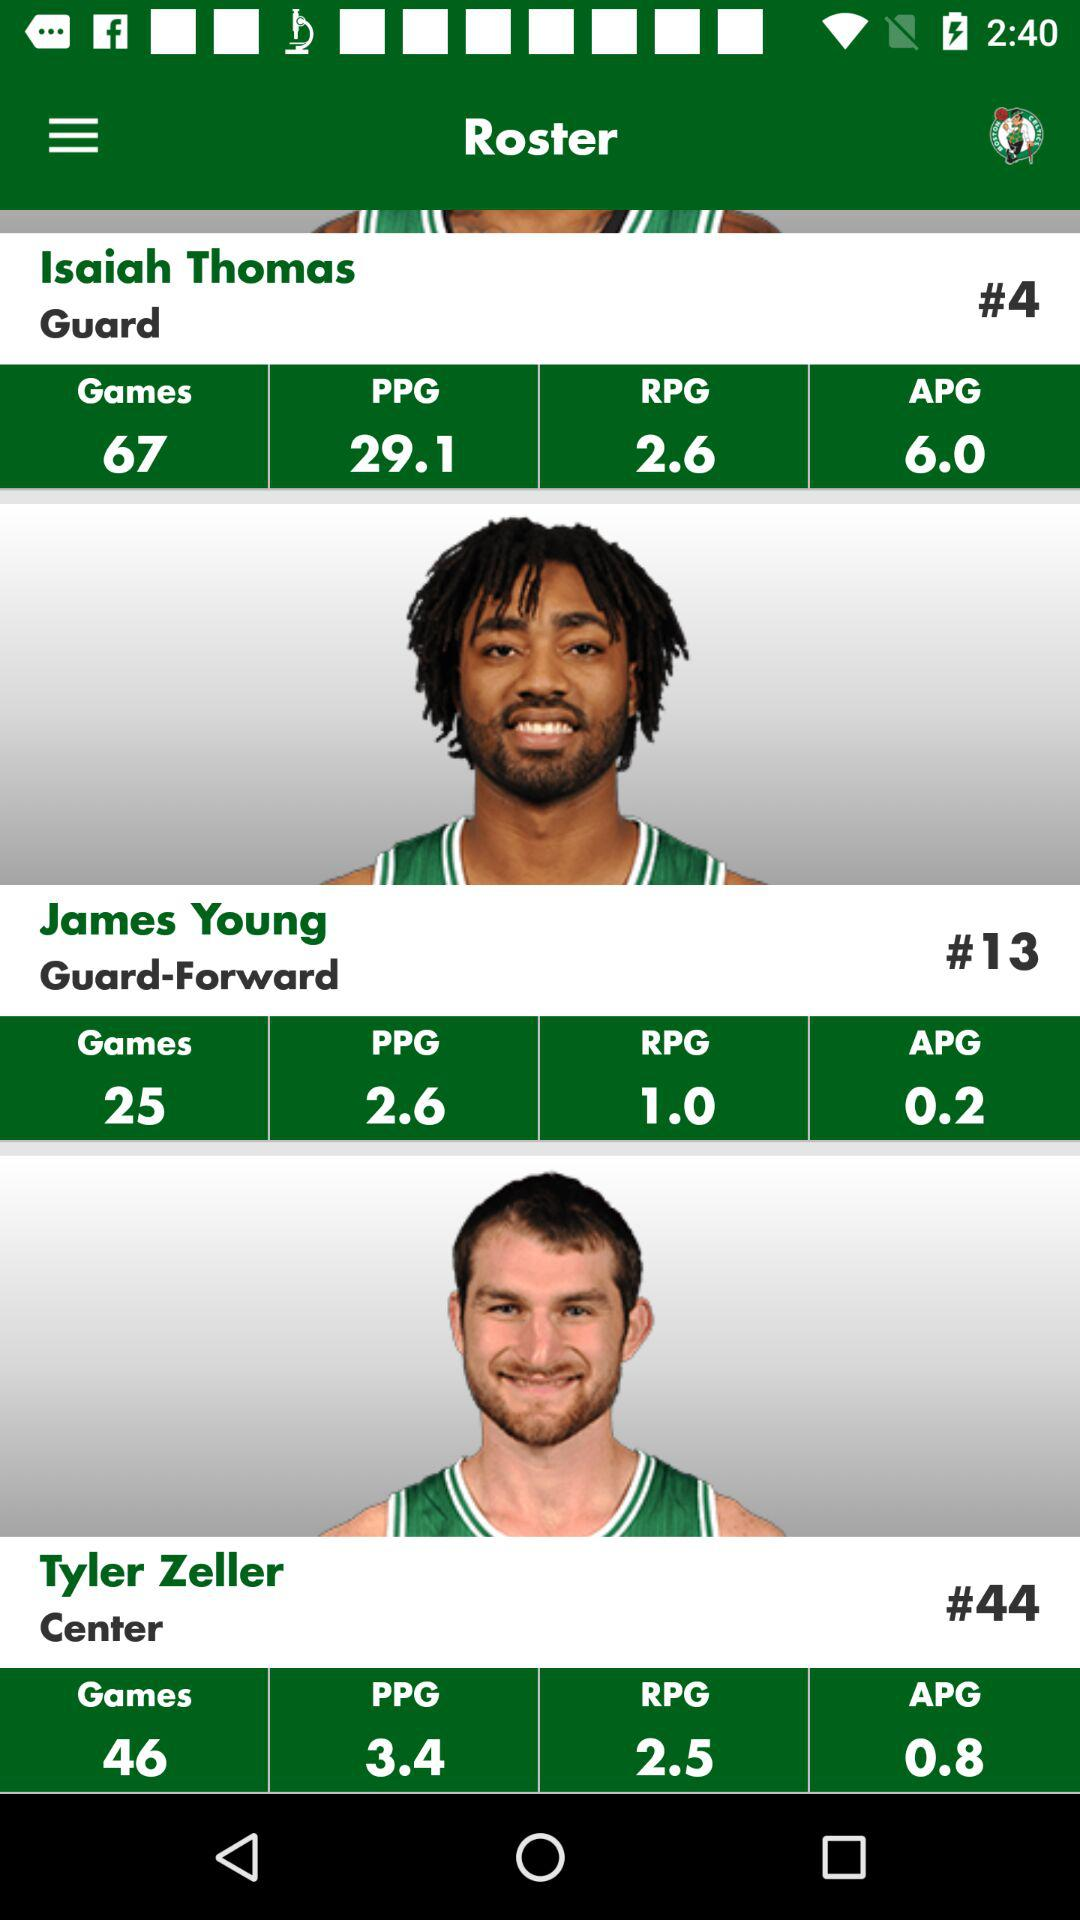What is the number of games played by Isaiah Thomas? The number of games played is 67. 